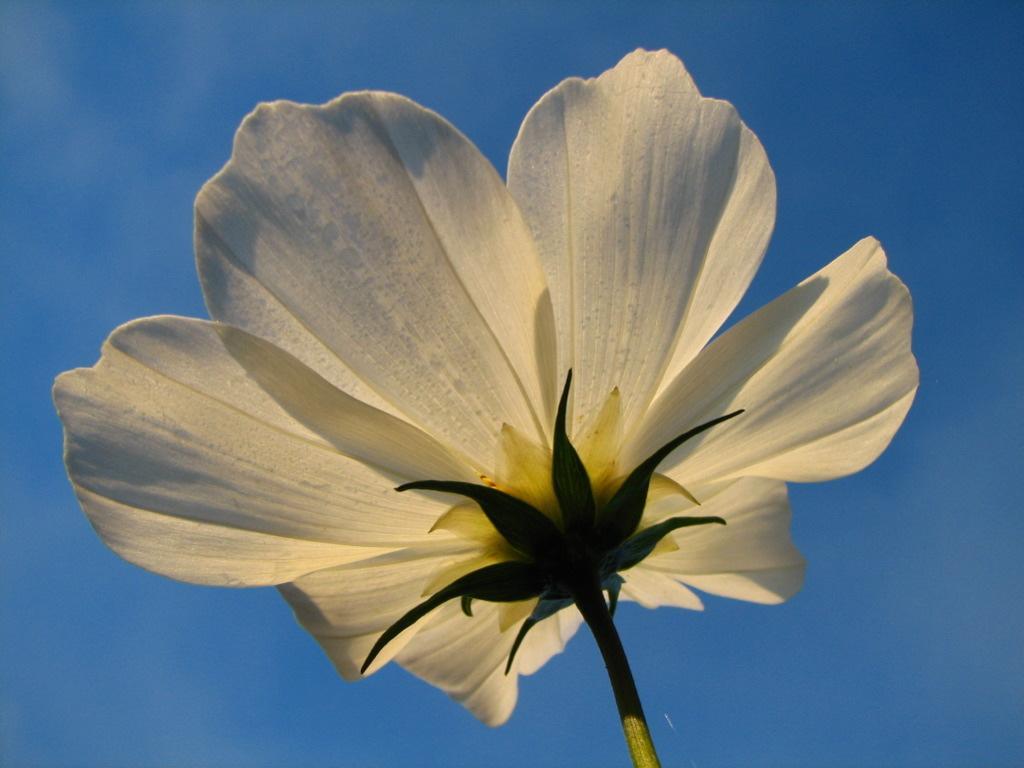Please provide a concise description of this image. In this image we can see a flower, and the sky. 